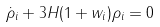<formula> <loc_0><loc_0><loc_500><loc_500>\dot { \rho } _ { i } + 3 H ( 1 + w _ { i } ) \rho _ { i } = 0</formula> 